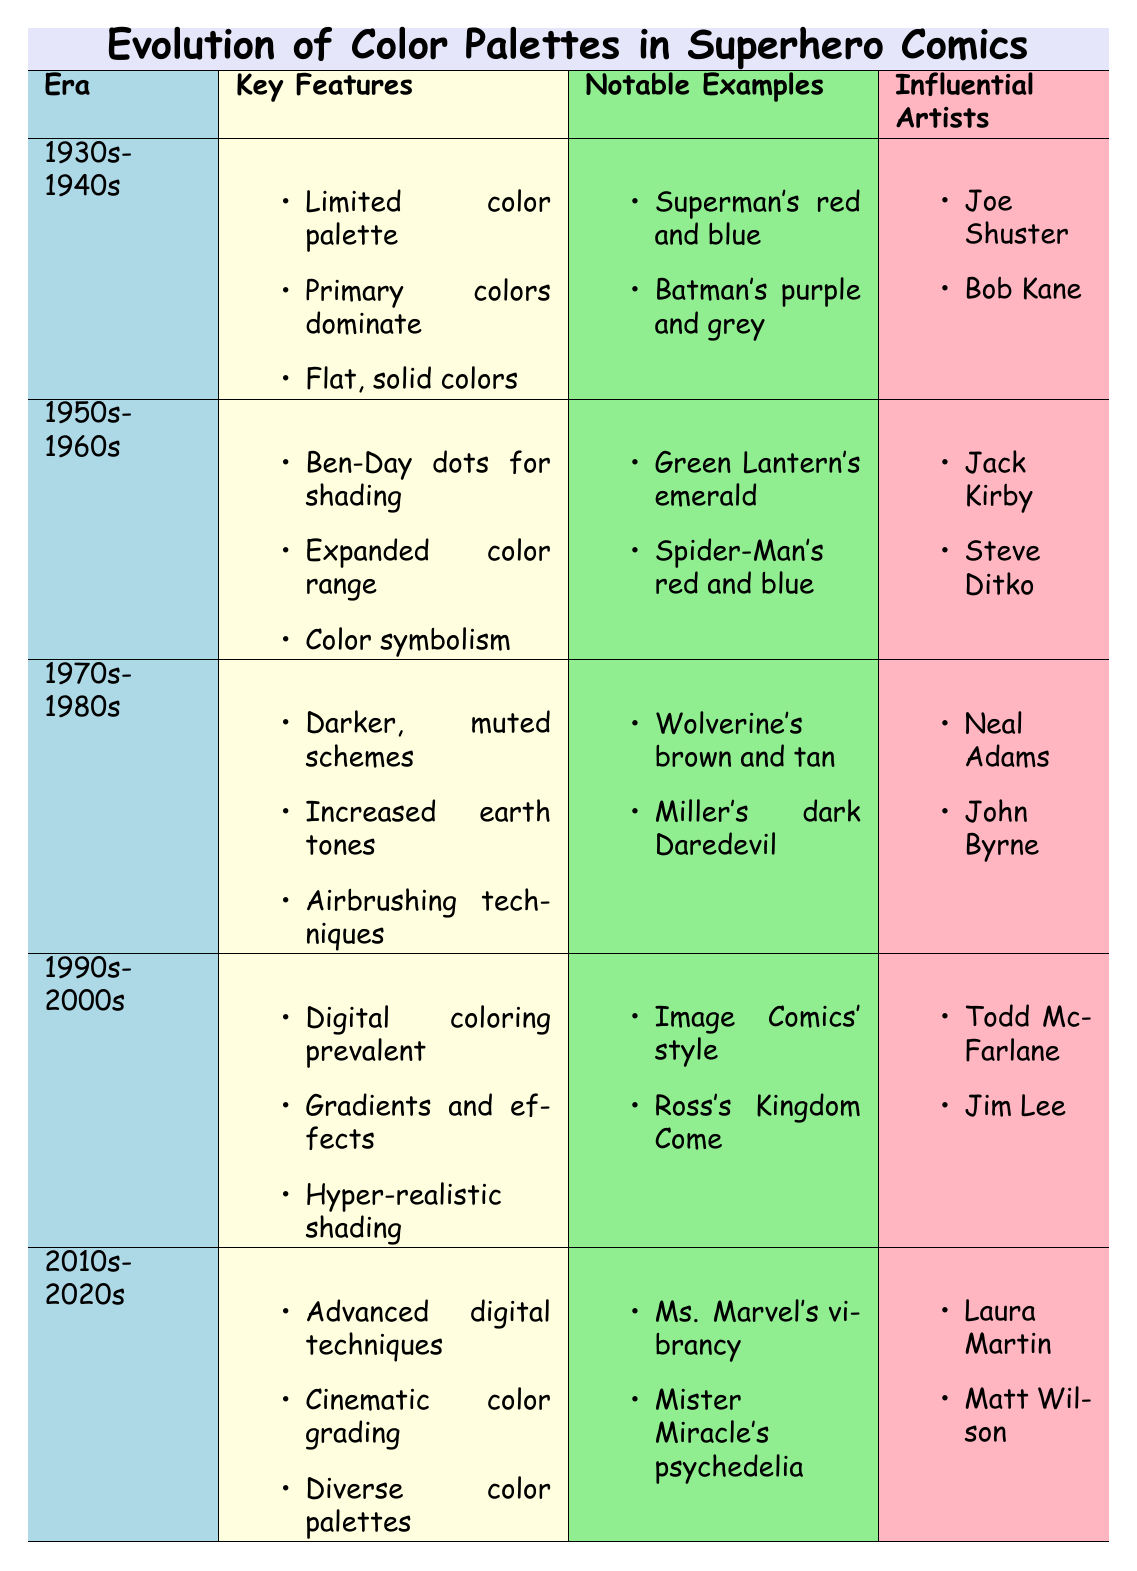What color schemes were dominant in the 1930s-1940s? The table lists "Primary colors dominate (red, blue, yellow)" as a key feature for the 1930s-1940s. Thus, the dominant color schemes were mostly the primary colors.
Answer: Primary colors Which influential artists worked during the 1970s-1980s? According to the table, the influential artists during the 1970s-1980s were Neal Adams and John Byrne.
Answer: Neal Adams, John Byrne Did the color palettes in the 1990s-2000s include earth tones? The key features for the 1990s-2000s do not mention earth tones; instead, they focus on "Digital coloring becomes prevalent" and "Increased use of gradients." Therefore, the answer is no.
Answer: No What is the trend regarding the use of shading from the 1950s-1960s to 1990s-2000s? In the 1950s-1960s, shading was introduced with Ben-Day dots, while in the 1990s-2000s, hyper-realistic shading techniques became prevalent. This indicates a trend of evolution from basic to advanced shading techniques.
Answer: Evolution from basic to advanced shading How many decades are represented in the timeline, and which era experienced expanded color schemes? The timeline covers five decades: 1930s-1940s, 1950s-1960s, 1970s-1980s, 1990s-2000s, and 2010s-2020s. The era that experienced expanded color schemes was the 1950s-1960s.
Answer: Five decades; 1950s-1960s What notable example from the 2010s-2020s reflects character diversity? The table indicates that "Ms. Marvel's vibrant and expressive colors" is a notable example that reflects character diversity in the 2010s-2020s.
Answer: Ms. Marvel's vibrant colors Which two artists are associated with the introduction of airbrushing techniques? The table lists Neal Adams and John Byrne as influential artists in the 1970s-1980s, where airbrushing techniques were introduced.
Answer: Neal Adams, John Byrne Was digital coloring prevalent in the 1980s? The key features for the 1980s do not mention digital coloring; instead, they point to muted color schemes and airbrushing techniques. Therefore, the answer is no.
Answer: No How does the use of color techniques differ from the 1930s-1940s to the 2010s-2020s? The 1930s-1940s features limited colors and flat styling, while the 2010s-2020s showcase advanced digital techniques and diverse palettes, indicating significant advancement in color techniques.
Answer: Significant advancement in color techniques 